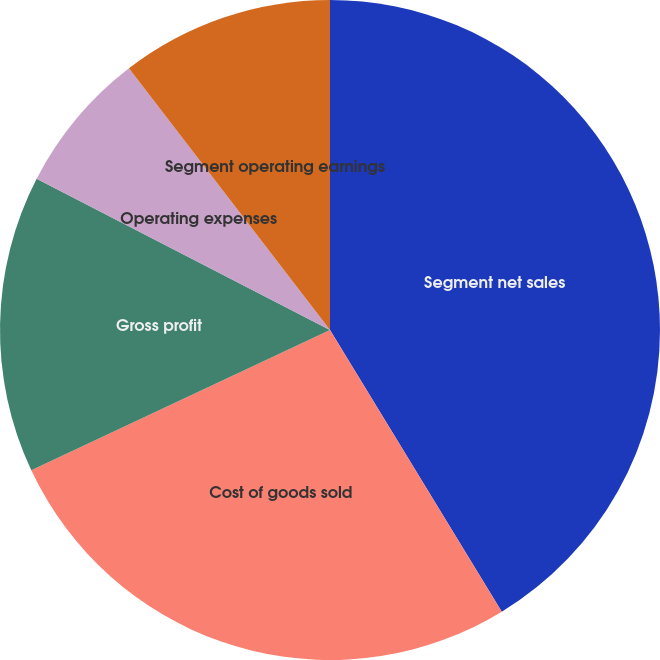Convert chart. <chart><loc_0><loc_0><loc_500><loc_500><pie_chart><fcel>Segment net sales<fcel>Cost of goods sold<fcel>Gross profit<fcel>Operating expenses<fcel>Segment operating earnings<nl><fcel>41.29%<fcel>26.73%<fcel>14.56%<fcel>7.0%<fcel>10.43%<nl></chart> 